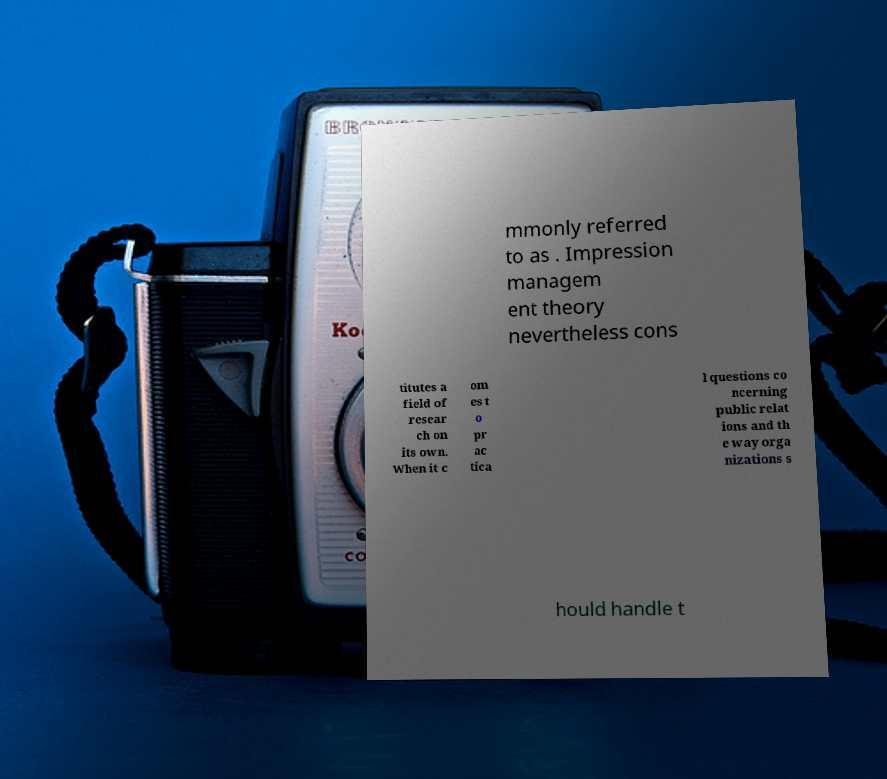Can you read and provide the text displayed in the image?This photo seems to have some interesting text. Can you extract and type it out for me? mmonly referred to as . Impression managem ent theory nevertheless cons titutes a field of resear ch on its own. When it c om es t o pr ac tica l questions co ncerning public relat ions and th e way orga nizations s hould handle t 